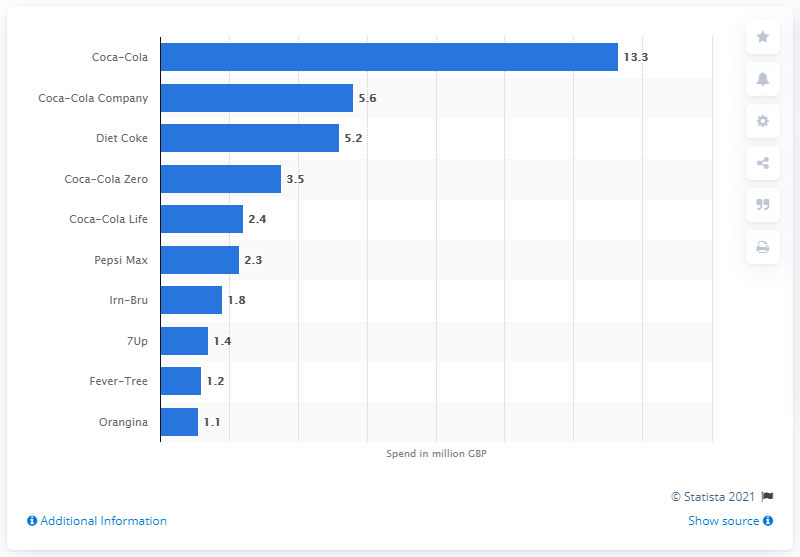Draw attention to some important aspects in this diagram. Coca-Cola spent 13.3% of its revenue on advertising in 2020. 